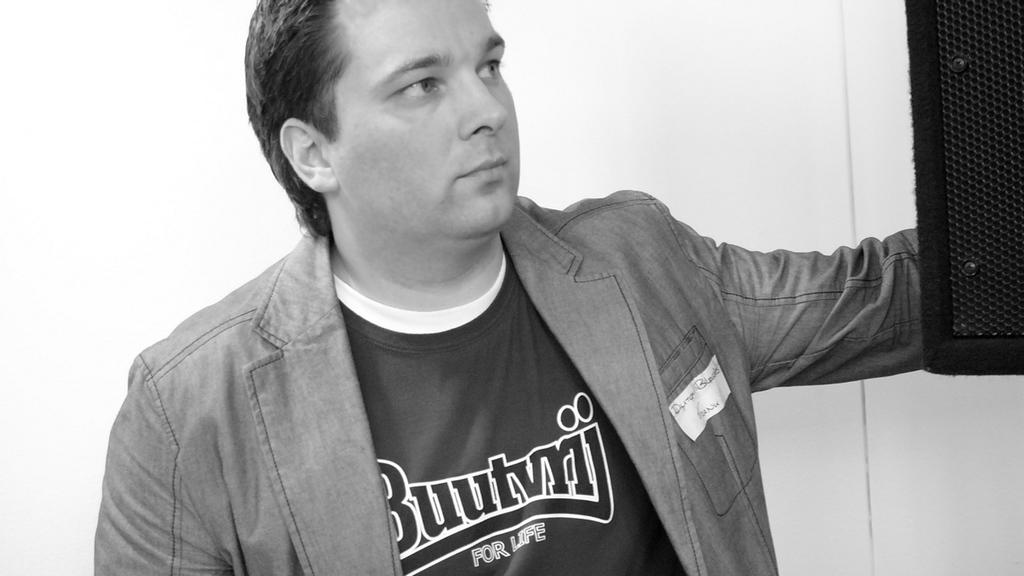Provide a one-sentence caption for the provided image. A man's shirt says Buutvrij for life on it. 